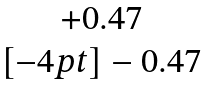Convert formula to latex. <formula><loc_0><loc_0><loc_500><loc_500>\begin{matrix} + 0 . 4 7 \\ [ - 4 p t ] - 0 . 4 7 \end{matrix}</formula> 